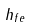Convert formula to latex. <formula><loc_0><loc_0><loc_500><loc_500>h _ { f e }</formula> 